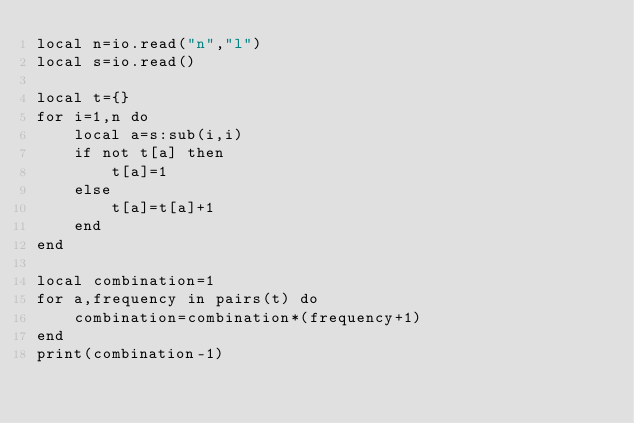<code> <loc_0><loc_0><loc_500><loc_500><_Lua_>local n=io.read("n","l")
local s=io.read()

local t={}
for i=1,n do
    local a=s:sub(i,i)
    if not t[a] then
        t[a]=1
    else
        t[a]=t[a]+1
    end
end

local combination=1
for a,frequency in pairs(t) do
    combination=combination*(frequency+1)
end
print(combination-1)</code> 